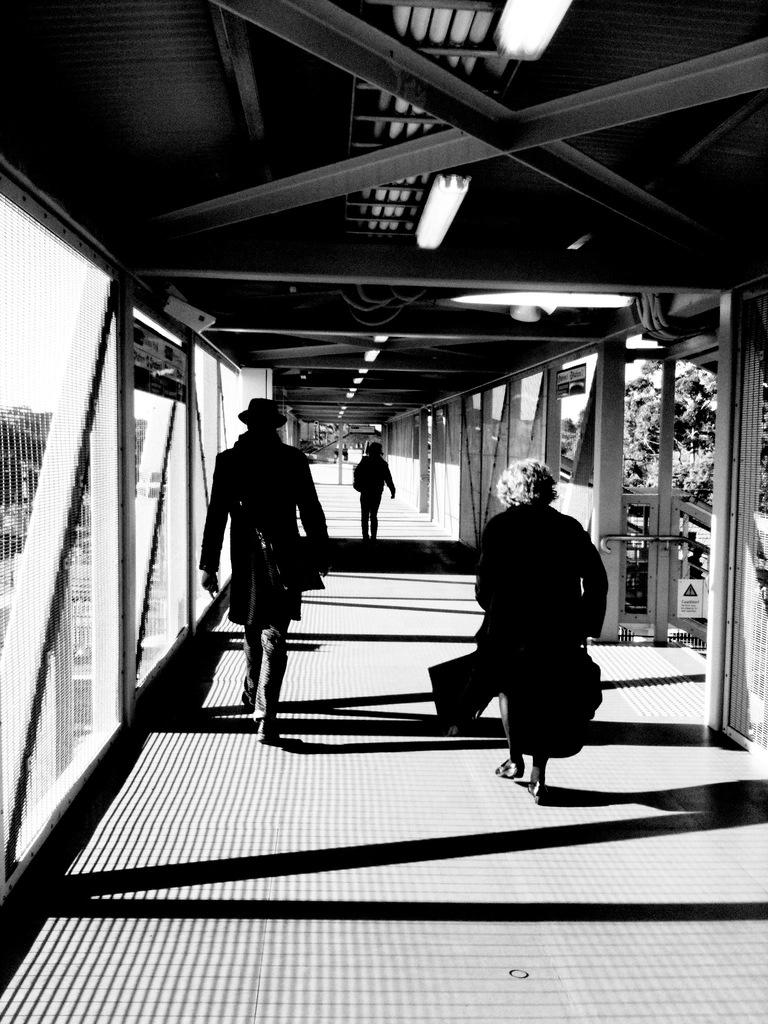How many people are in the image? There is a group of persons in the image. What are the persons doing in the image? The persons are walking on a bridge. What can be seen in the background of the image? There are lights and trees visible in the image. What is the color scheme of the image? The image is in black and white. What type of suit is the coach wearing in the image? There is no coach or suit present in the image. What kind of shock can be seen affecting the persons in the image? There is no shock or any indication of distress visible in the image; the persons are simply walking on a bridge. 